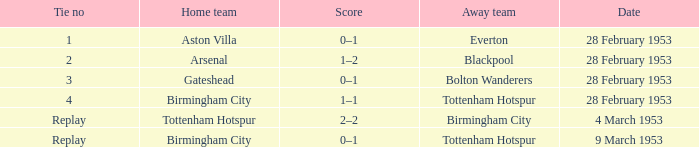Which Home team has an Away team of everton? Aston Villa. 